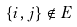<formula> <loc_0><loc_0><loc_500><loc_500>\{ i , j \} \notin E</formula> 